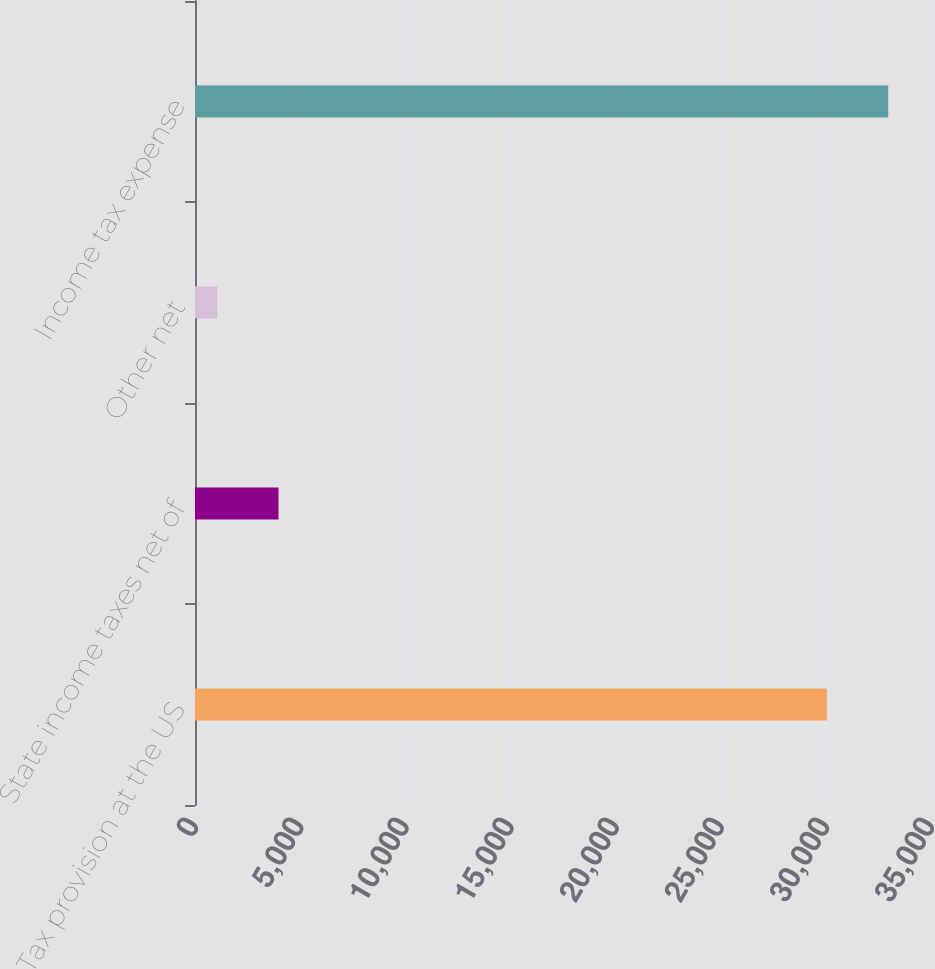<chart> <loc_0><loc_0><loc_500><loc_500><bar_chart><fcel>Tax provision at the US<fcel>State income taxes net of<fcel>Other net<fcel>Income tax expense<nl><fcel>30050<fcel>3972.8<fcel>1056<fcel>32966.8<nl></chart> 